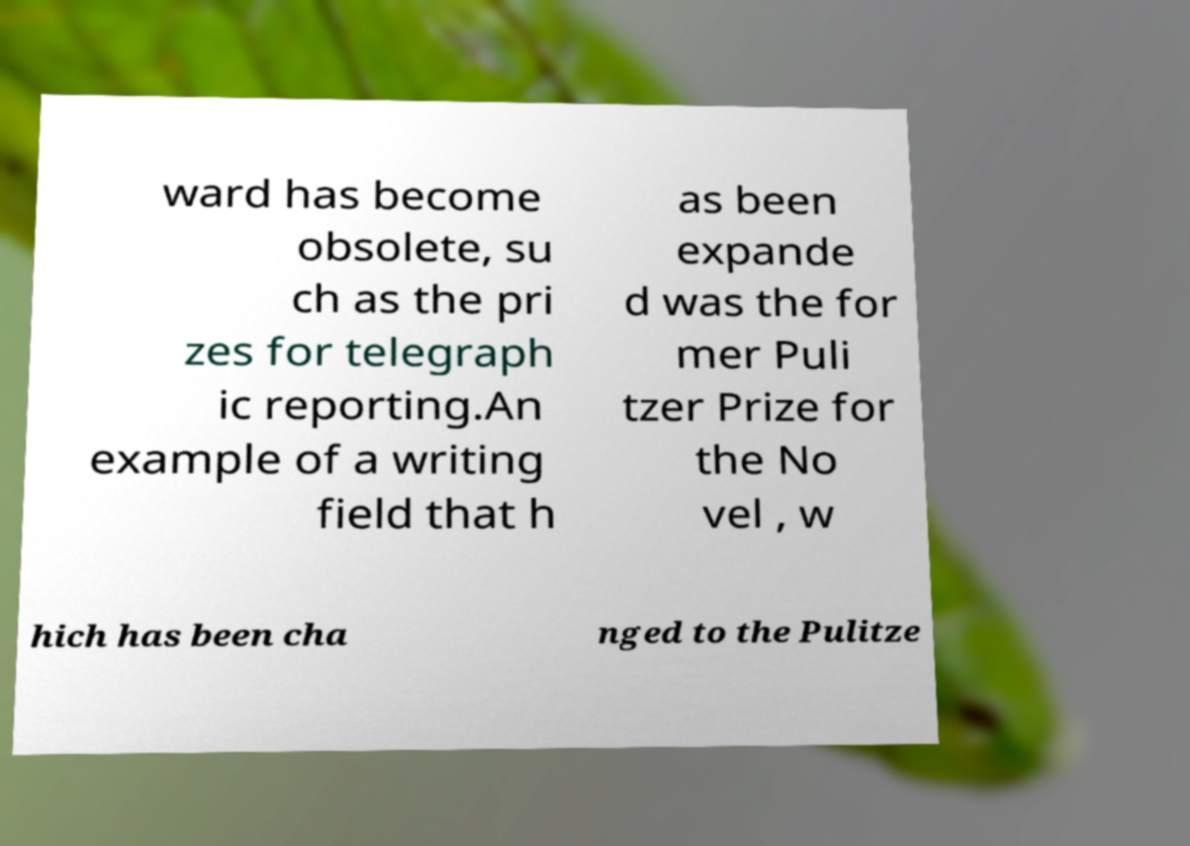Could you assist in decoding the text presented in this image and type it out clearly? ward has become obsolete, su ch as the pri zes for telegraph ic reporting.An example of a writing field that h as been expande d was the for mer Puli tzer Prize for the No vel , w hich has been cha nged to the Pulitze 